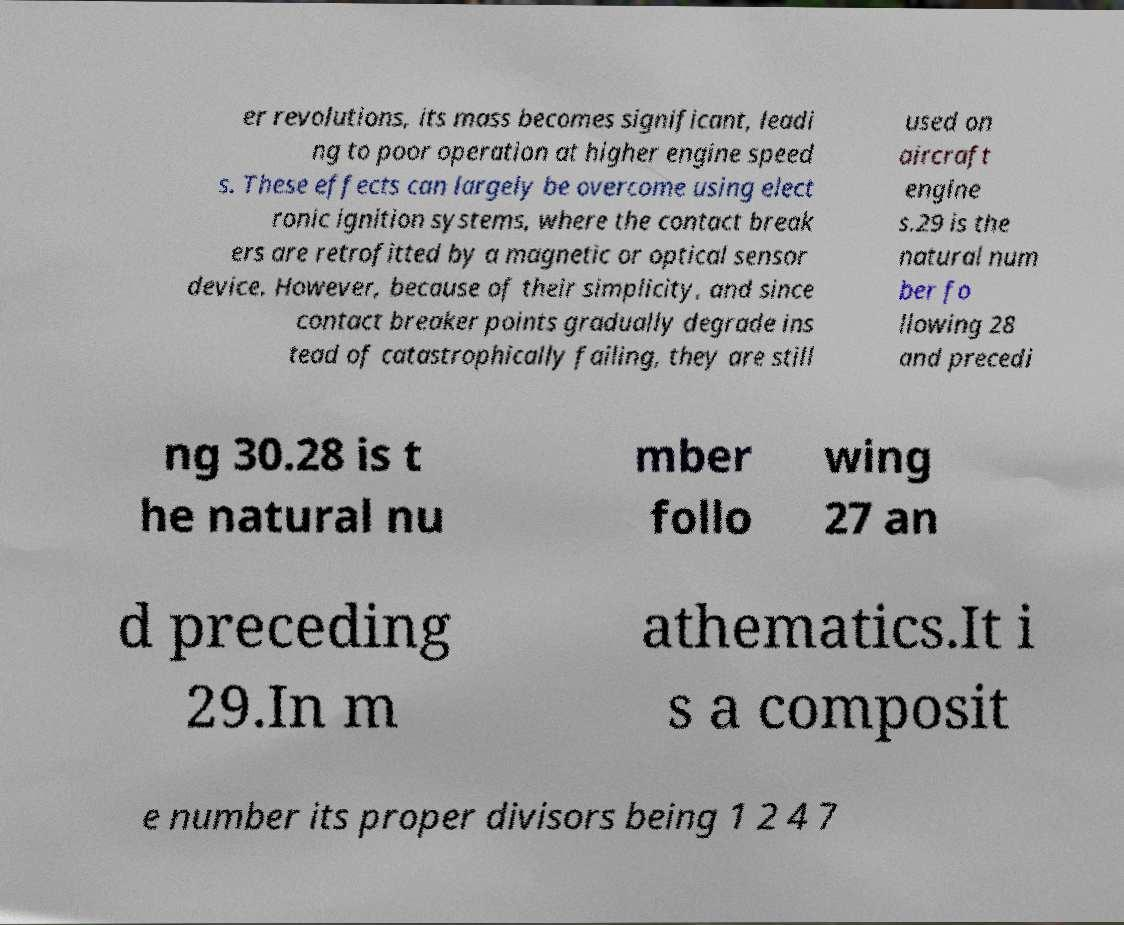Can you read and provide the text displayed in the image?This photo seems to have some interesting text. Can you extract and type it out for me? er revolutions, its mass becomes significant, leadi ng to poor operation at higher engine speed s. These effects can largely be overcome using elect ronic ignition systems, where the contact break ers are retrofitted by a magnetic or optical sensor device. However, because of their simplicity, and since contact breaker points gradually degrade ins tead of catastrophically failing, they are still used on aircraft engine s.29 is the natural num ber fo llowing 28 and precedi ng 30.28 is t he natural nu mber follo wing 27 an d preceding 29.In m athematics.It i s a composit e number its proper divisors being 1 2 4 7 